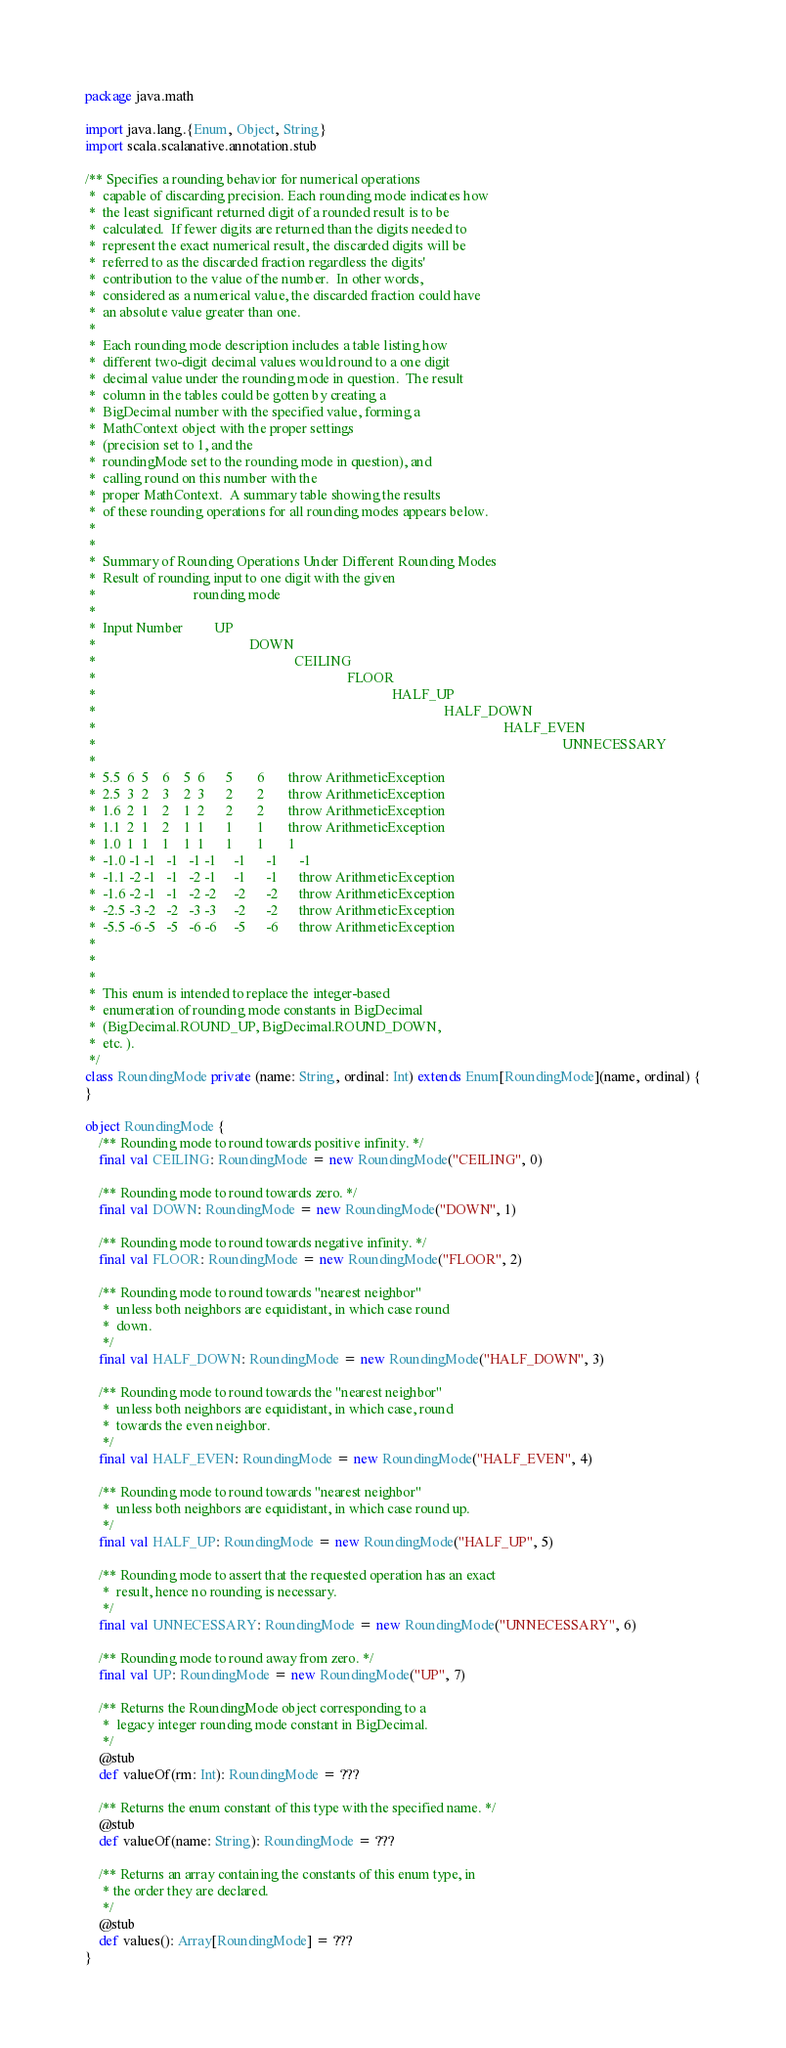Convert code to text. <code><loc_0><loc_0><loc_500><loc_500><_Scala_>package java.math

import java.lang.{Enum, Object, String}
import scala.scalanative.annotation.stub

/** Specifies a rounding behavior for numerical operations
 *  capable of discarding precision. Each rounding mode indicates how
 *  the least significant returned digit of a rounded result is to be
 *  calculated.  If fewer digits are returned than the digits needed to
 *  represent the exact numerical result, the discarded digits will be
 *  referred to as the discarded fraction regardless the digits'
 *  contribution to the value of the number.  In other words,
 *  considered as a numerical value, the discarded fraction could have
 *  an absolute value greater than one.
 * 
 *  Each rounding mode description includes a table listing how
 *  different two-digit decimal values would round to a one digit
 *  decimal value under the rounding mode in question.  The result
 *  column in the tables could be gotten by creating a
 *  BigDecimal number with the specified value, forming a
 *  MathContext object with the proper settings
 *  (precision set to 1, and the
 *  roundingMode set to the rounding mode in question), and
 *  calling round on this number with the
 *  proper MathContext.  A summary table showing the results
 *  of these rounding operations for all rounding modes appears below.
 * 
 * 
 *  Summary of Rounding Operations Under Different Rounding Modes
 *  Result of rounding input to one digit with the given
 *                            rounding mode
 *  
 *  Input Number         UP
 *                                            DOWN
 *                                                         CEILING
 *                                                                        FLOOR
 *                                                                                     HALF_UP
 *                                                                                                    HALF_DOWN
 *                                                                                                                     HALF_EVEN
 *                                                                                                                                      UNNECESSARY
 * 
 *  5.5  6  5    6    5  6      5       6       throw ArithmeticException
 *  2.5  3  2    3    2  3      2       2       throw ArithmeticException
 *  1.6  2  1    2    1  2      2       2       throw ArithmeticException
 *  1.1  2  1    2    1  1      1       1       throw ArithmeticException
 *  1.0  1  1    1    1  1      1       1       1
 *  -1.0 -1 -1   -1   -1 -1     -1      -1      -1
 *  -1.1 -2 -1   -1   -2 -1     -1      -1      throw ArithmeticException
 *  -1.6 -2 -1   -1   -2 -2     -2      -2      throw ArithmeticException
 *  -2.5 -3 -2   -2   -3 -3     -2      -2      throw ArithmeticException
 *  -5.5 -6 -5   -5   -6 -6     -5      -6      throw ArithmeticException
 * 
 * 
 * 
 *  This enum is intended to replace the integer-based
 *  enumeration of rounding mode constants in BigDecimal
 *  (BigDecimal.ROUND_UP, BigDecimal.ROUND_DOWN,
 *  etc. ).
 */
class RoundingMode private (name: String, ordinal: Int) extends Enum[RoundingMode](name, ordinal) {
}

object RoundingMode {
    /** Rounding mode to round towards positive infinity. */
    final val CEILING: RoundingMode = new RoundingMode("CEILING", 0)

    /** Rounding mode to round towards zero. */
    final val DOWN: RoundingMode = new RoundingMode("DOWN", 1)

    /** Rounding mode to round towards negative infinity. */
    final val FLOOR: RoundingMode = new RoundingMode("FLOOR", 2)

    /** Rounding mode to round towards "nearest neighbor"
     *  unless both neighbors are equidistant, in which case round
     *  down.
     */
    final val HALF_DOWN: RoundingMode = new RoundingMode("HALF_DOWN", 3)

    /** Rounding mode to round towards the "nearest neighbor"
     *  unless both neighbors are equidistant, in which case, round
     *  towards the even neighbor.
     */
    final val HALF_EVEN: RoundingMode = new RoundingMode("HALF_EVEN", 4)

    /** Rounding mode to round towards "nearest neighbor"
     *  unless both neighbors are equidistant, in which case round up.
     */
    final val HALF_UP: RoundingMode = new RoundingMode("HALF_UP", 5)

    /** Rounding mode to assert that the requested operation has an exact
     *  result, hence no rounding is necessary.
     */
    final val UNNECESSARY: RoundingMode = new RoundingMode("UNNECESSARY", 6)

    /** Rounding mode to round away from zero. */
    final val UP: RoundingMode = new RoundingMode("UP", 7)

    /** Returns the RoundingMode object corresponding to a
     *  legacy integer rounding mode constant in BigDecimal.
     */
    @stub
    def valueOf(rm: Int): RoundingMode = ???

    /** Returns the enum constant of this type with the specified name. */
    @stub
    def valueOf(name: String): RoundingMode = ???

    /** Returns an array containing the constants of this enum type, in
     * the order they are declared.
     */
    @stub
    def values(): Array[RoundingMode] = ???
}
</code> 